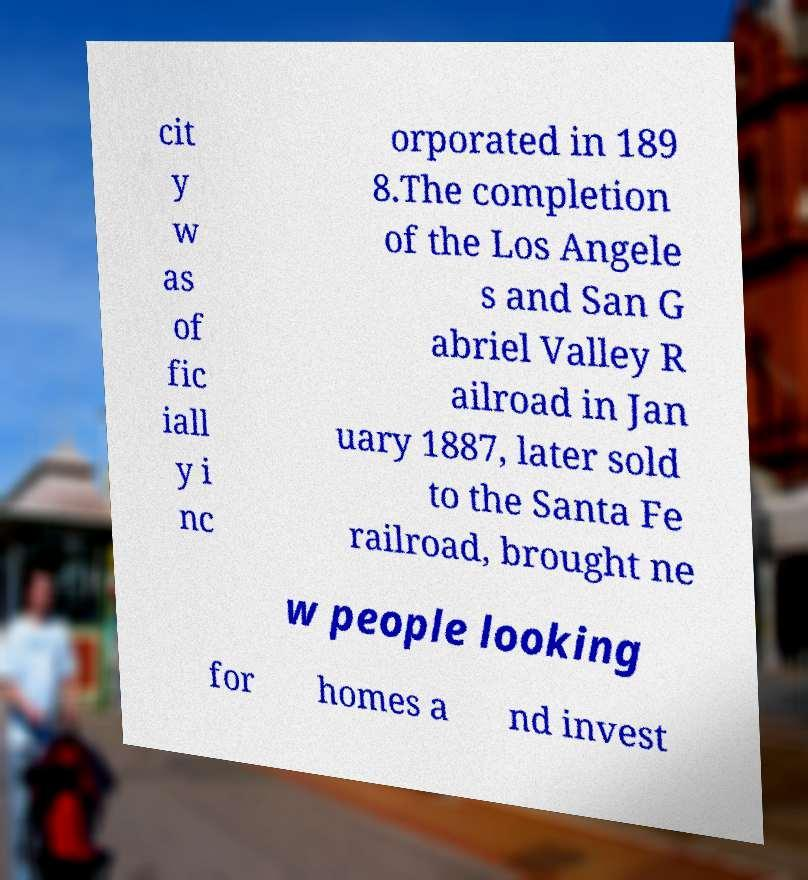I need the written content from this picture converted into text. Can you do that? cit y w as of fic iall y i nc orporated in 189 8.The completion of the Los Angele s and San G abriel Valley R ailroad in Jan uary 1887, later sold to the Santa Fe railroad, brought ne w people looking for homes a nd invest 